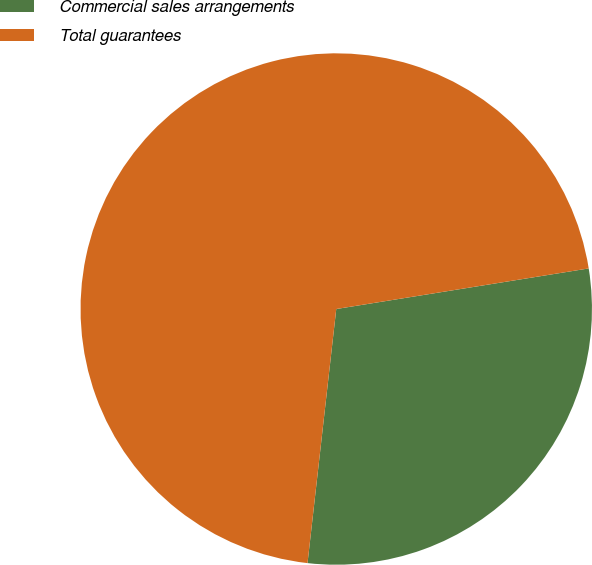Convert chart to OTSL. <chart><loc_0><loc_0><loc_500><loc_500><pie_chart><fcel>Commercial sales arrangements<fcel>Total guarantees<nl><fcel>29.33%<fcel>70.67%<nl></chart> 